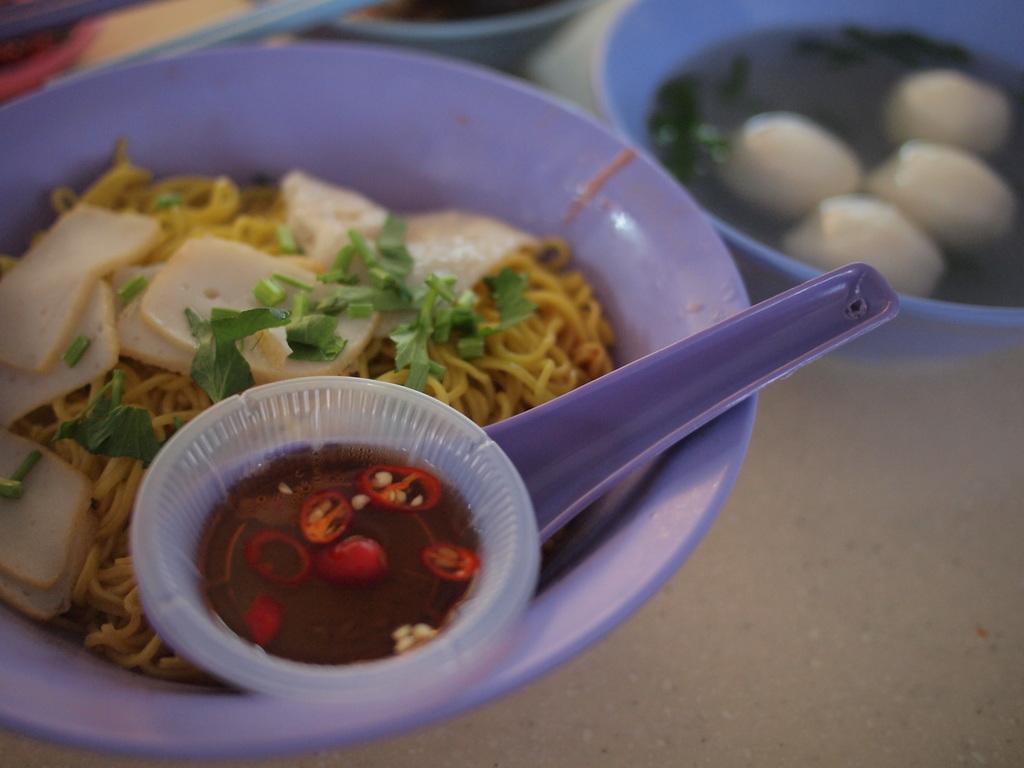Please provide a concise description of this image. In this image there is a table and we can see bowls containing food and sauce placed on the table. 